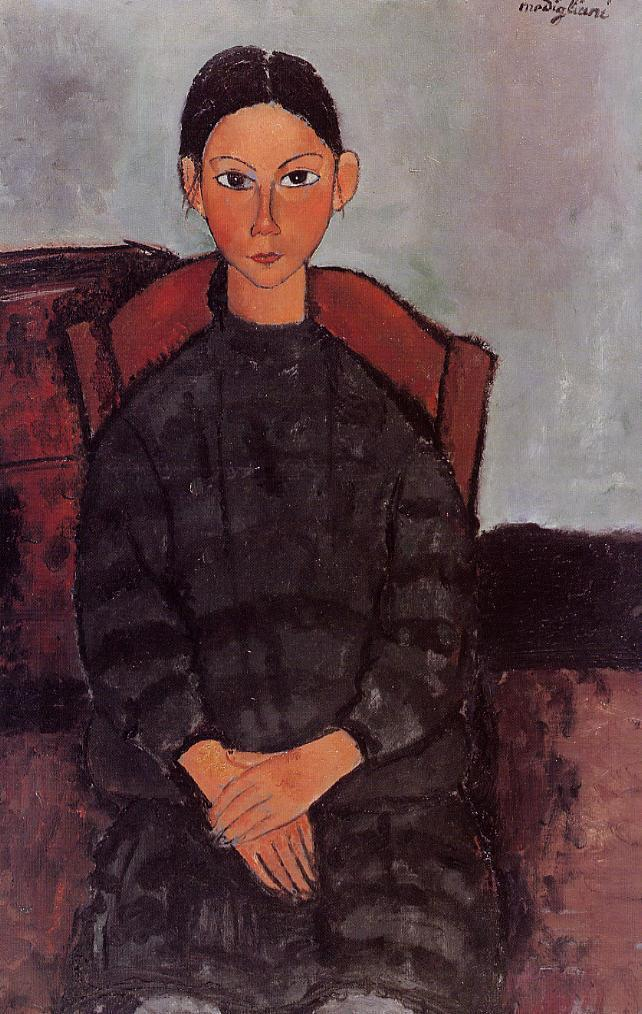What emotions do you perceive in the subject's expression? The woman's expression appears contemplative and serene, with a hint of solemnity. Her eyes maintain a direct gaze, which suggests a strong presence and perhaps an inner confidence. There are no overt signs of joy or sorrow, leaving her emotional state open to interpretation. The overall serenity suggests a composed and reflective mood. 